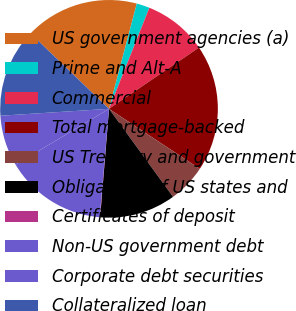Convert chart to OTSL. <chart><loc_0><loc_0><loc_500><loc_500><pie_chart><fcel>US government agencies (a)<fcel>Prime and Alt-A<fcel>Commercial<fcel>Total mortgage-backed<fcel>US Treasury and government<fcel>Obligations of US states and<fcel>Certificates of deposit<fcel>Non-US government debt<fcel>Corporate debt securities<fcel>Collateralized loan<nl><fcel>16.93%<fcel>1.94%<fcel>9.44%<fcel>18.81%<fcel>5.69%<fcel>11.31%<fcel>0.07%<fcel>15.06%<fcel>7.56%<fcel>13.19%<nl></chart> 